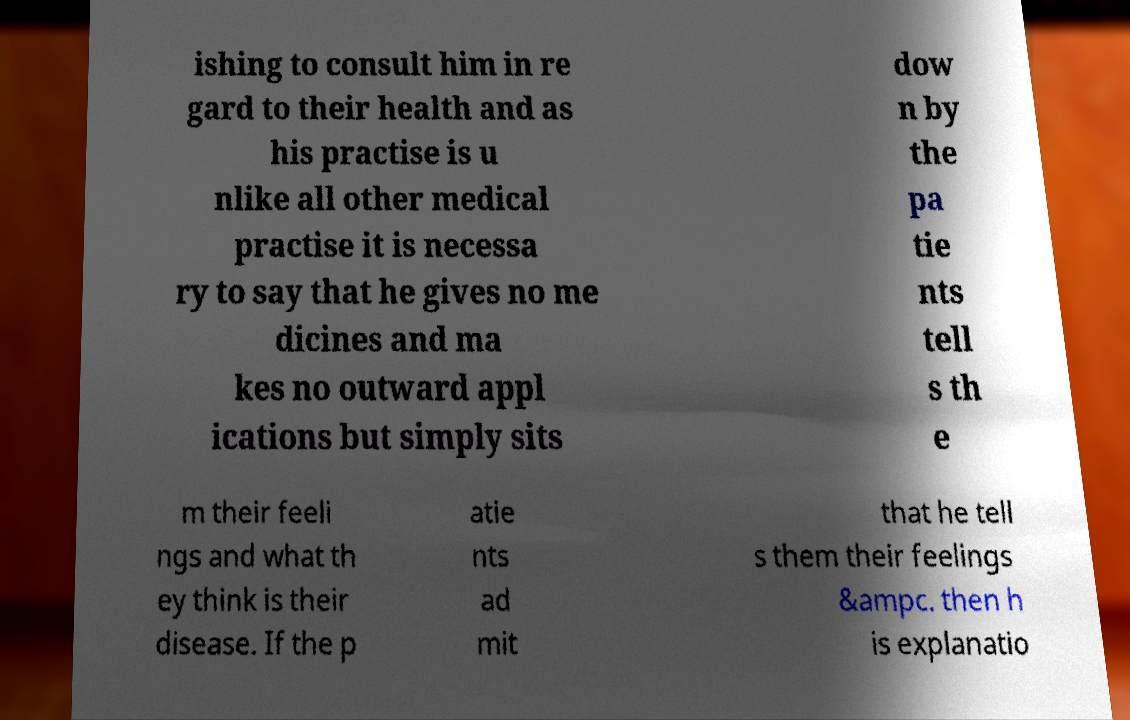Please read and relay the text visible in this image. What does it say? ishing to consult him in re gard to their health and as his practise is u nlike all other medical practise it is necessa ry to say that he gives no me dicines and ma kes no outward appl ications but simply sits dow n by the pa tie nts tell s th e m their feeli ngs and what th ey think is their disease. If the p atie nts ad mit that he tell s them their feelings &ampc. then h is explanatio 